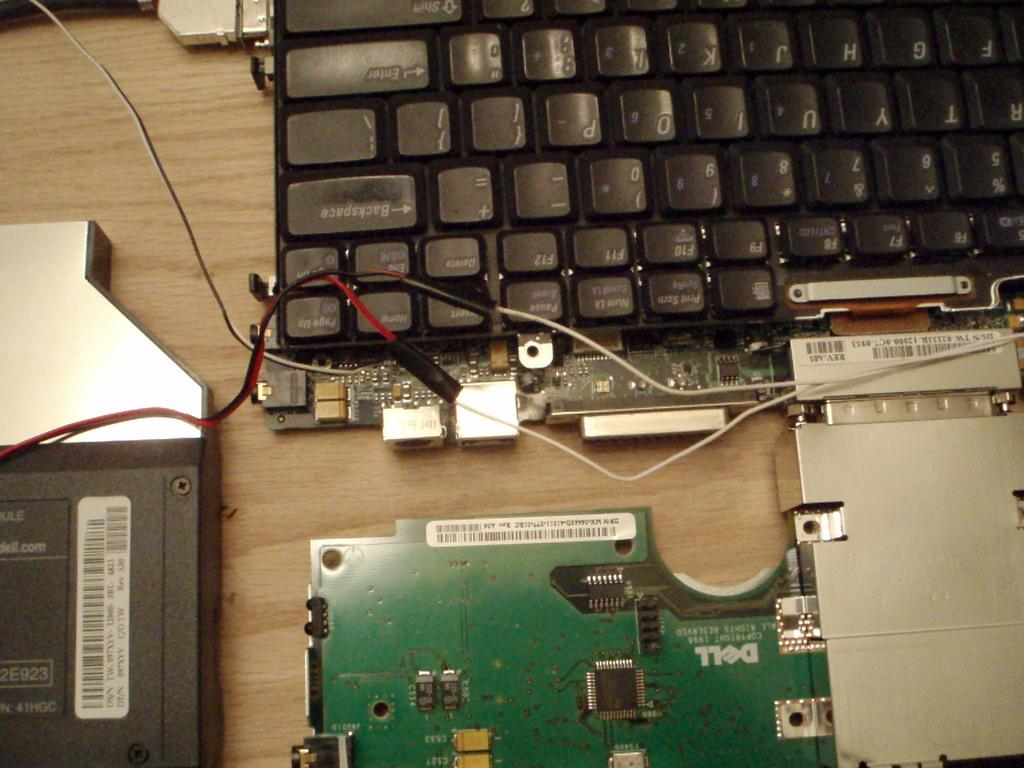<image>
Write a terse but informative summary of the picture. A dell computer part is beneath a keyboard. 